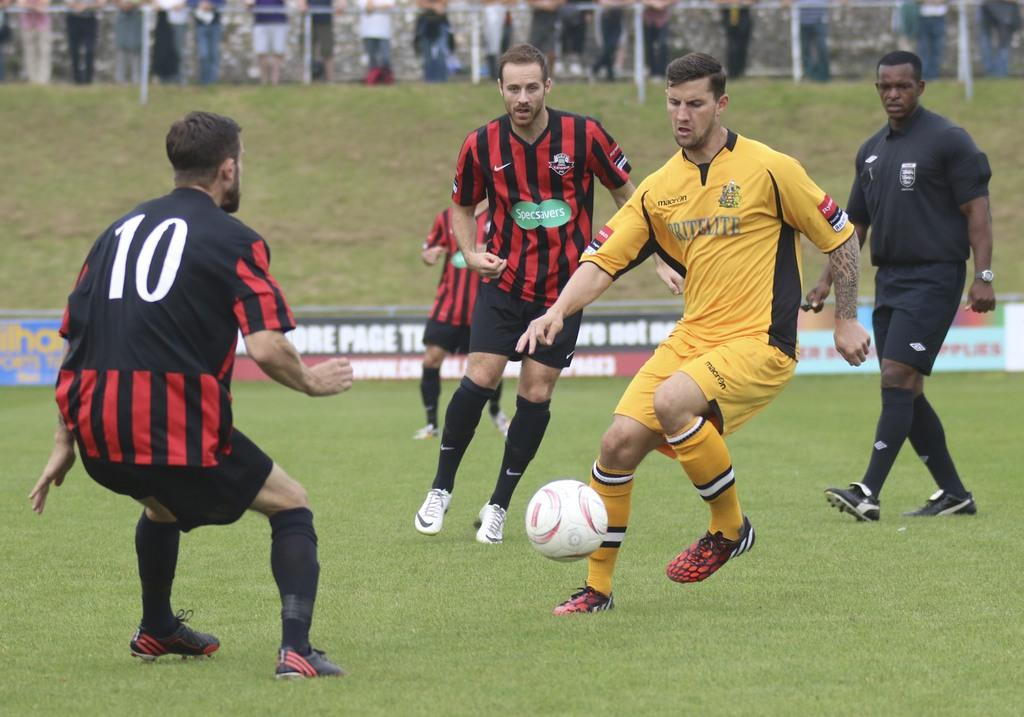What are the people in the image doing? The people in the image are playing on the ground. What object can be seen in the image that they might be using for their game? There is a ball in the image that they might be using. What type of surface are they playing on? There is grass in the image, which is the surface they are playing on. What structures can be seen in the image besides the people playing? There are poles, hoardings, and a wall visible in the image. Are there any other people in the image besides the ones playing? Yes, there are people in the background of the image. What type of grape is being used to destroy the poles in the image? There is no grape present in the image, nor is there any destruction of poles. 